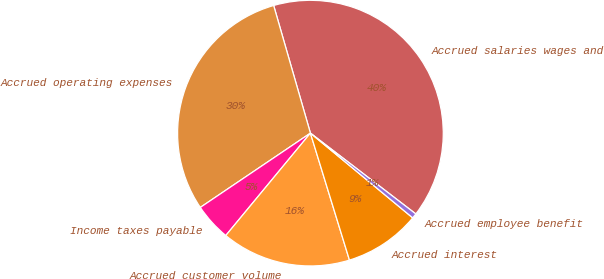Convert chart to OTSL. <chart><loc_0><loc_0><loc_500><loc_500><pie_chart><fcel>Accrued salaries wages and<fcel>Accrued operating expenses<fcel>Income taxes payable<fcel>Accrued customer volume<fcel>Accrued interest<fcel>Accrued employee benefit<nl><fcel>39.87%<fcel>29.98%<fcel>4.56%<fcel>15.74%<fcel>9.24%<fcel>0.6%<nl></chart> 